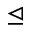<formula> <loc_0><loc_0><loc_500><loc_500>\triangleleft e q</formula> 